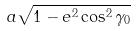Convert formula to latex. <formula><loc_0><loc_0><loc_500><loc_500>a \sqrt { 1 - e ^ { 2 } \cos ^ { 2 } \gamma _ { 0 } }</formula> 